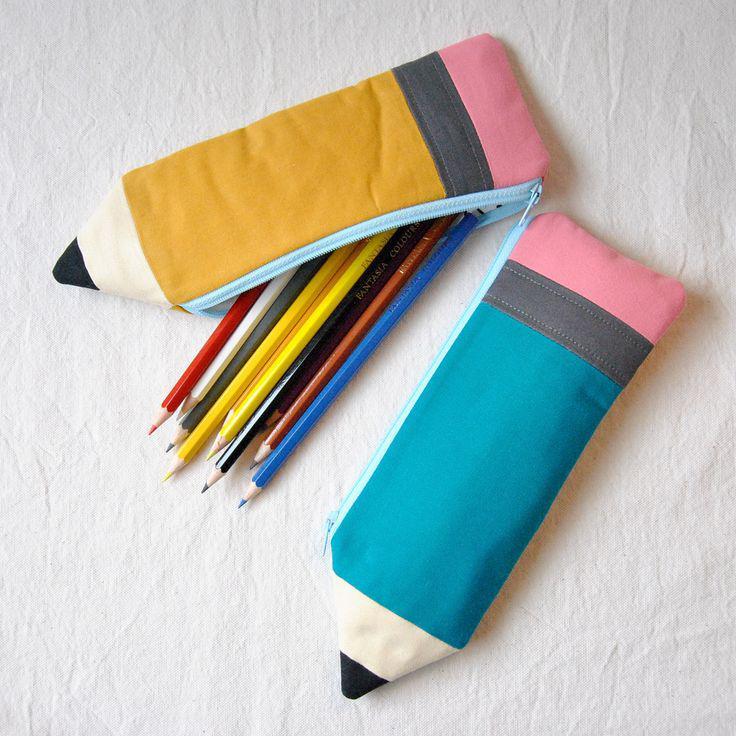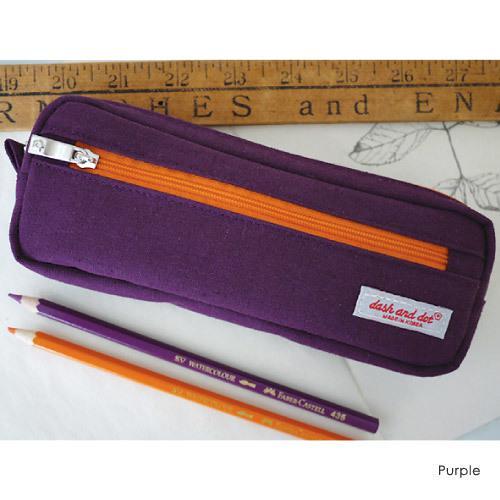The first image is the image on the left, the second image is the image on the right. Given the left and right images, does the statement "A pencil case in one image is multicolored with a top zipper, while four zippered cases in the second image are a different style." hold true? Answer yes or no. No. The first image is the image on the left, the second image is the image on the right. For the images shown, is this caption "there is a pencil pouch with flamingos and flowers on it" true? Answer yes or no. No. 